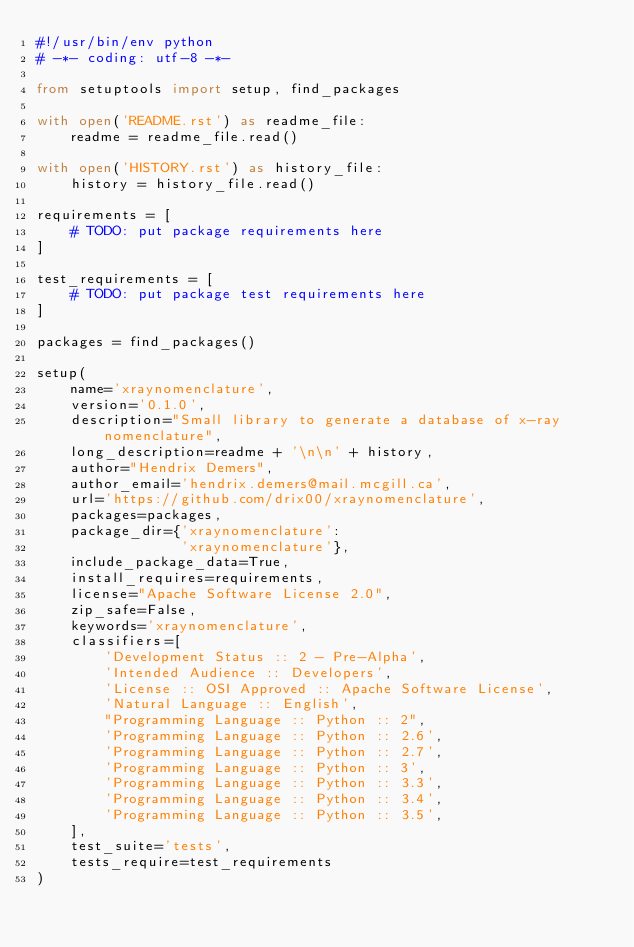Convert code to text. <code><loc_0><loc_0><loc_500><loc_500><_Python_>#!/usr/bin/env python
# -*- coding: utf-8 -*-

from setuptools import setup, find_packages

with open('README.rst') as readme_file:
    readme = readme_file.read()

with open('HISTORY.rst') as history_file:
    history = history_file.read()

requirements = [
    # TODO: put package requirements here
]

test_requirements = [
    # TODO: put package test requirements here
]

packages = find_packages()

setup(
    name='xraynomenclature',
    version='0.1.0',
    description="Small library to generate a database of x-ray nomenclature",
    long_description=readme + '\n\n' + history,
    author="Hendrix Demers",
    author_email='hendrix.demers@mail.mcgill.ca',
    url='https://github.com/drix00/xraynomenclature',
    packages=packages,
    package_dir={'xraynomenclature':
                 'xraynomenclature'},
    include_package_data=True,
    install_requires=requirements,
    license="Apache Software License 2.0",
    zip_safe=False,
    keywords='xraynomenclature',
    classifiers=[
        'Development Status :: 2 - Pre-Alpha',
        'Intended Audience :: Developers',
        'License :: OSI Approved :: Apache Software License',
        'Natural Language :: English',
        "Programming Language :: Python :: 2",
        'Programming Language :: Python :: 2.6',
        'Programming Language :: Python :: 2.7',
        'Programming Language :: Python :: 3',
        'Programming Language :: Python :: 3.3',
        'Programming Language :: Python :: 3.4',
        'Programming Language :: Python :: 3.5',
    ],
    test_suite='tests',
    tests_require=test_requirements
)
</code> 